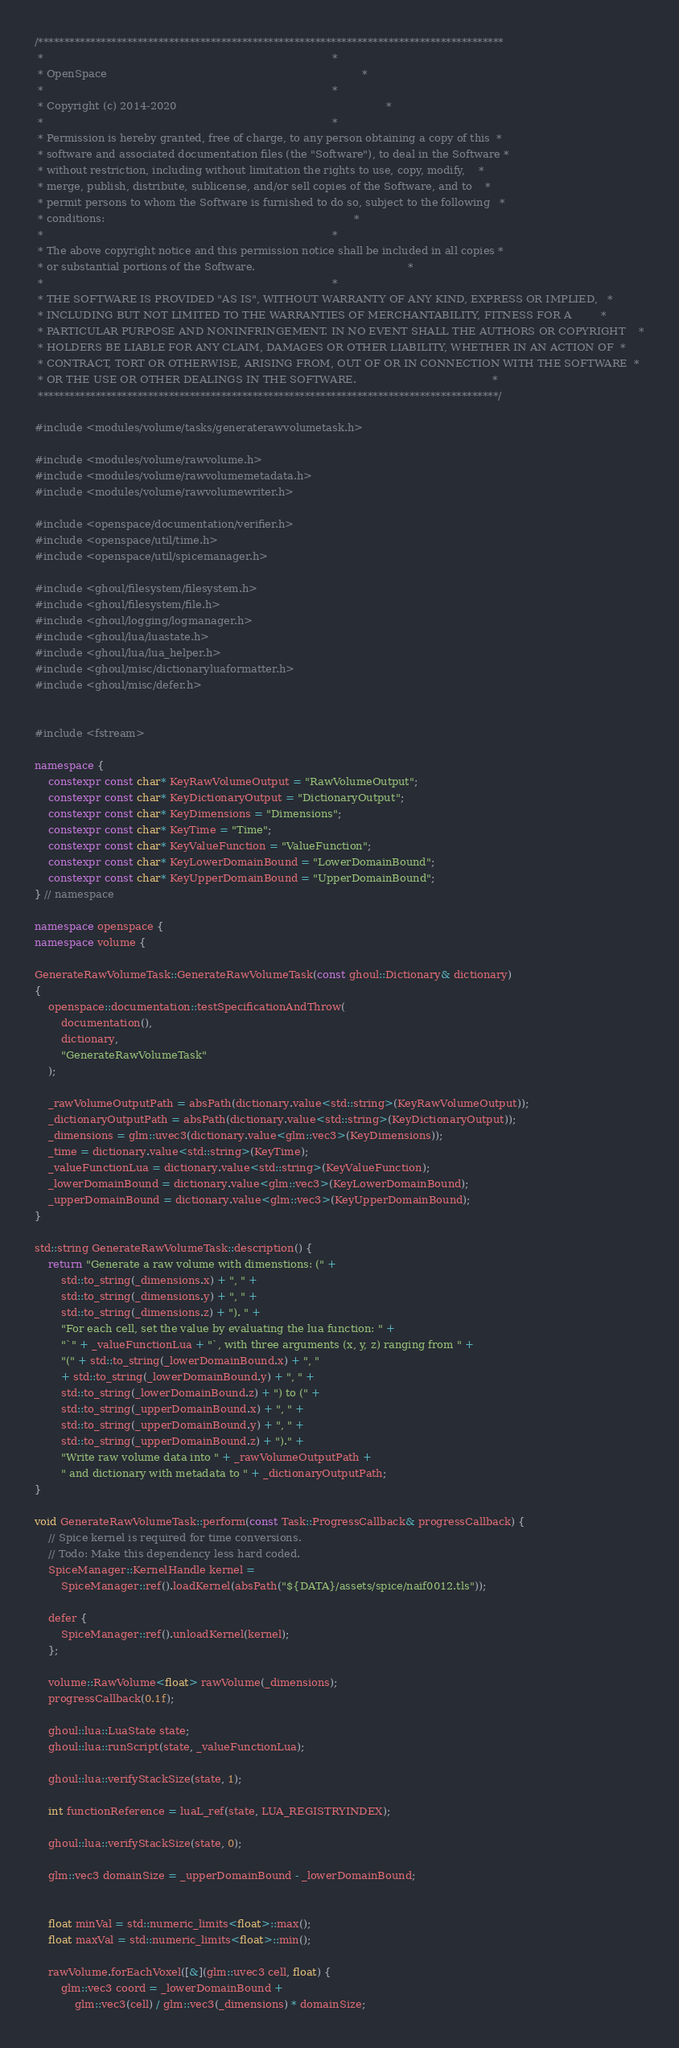<code> <loc_0><loc_0><loc_500><loc_500><_C++_>/*****************************************************************************************
 *                                                                                       *
 * OpenSpace                                                                             *
 *                                                                                       *
 * Copyright (c) 2014-2020                                                               *
 *                                                                                       *
 * Permission is hereby granted, free of charge, to any person obtaining a copy of this  *
 * software and associated documentation files (the "Software"), to deal in the Software *
 * without restriction, including without limitation the rights to use, copy, modify,    *
 * merge, publish, distribute, sublicense, and/or sell copies of the Software, and to    *
 * permit persons to whom the Software is furnished to do so, subject to the following   *
 * conditions:                                                                           *
 *                                                                                       *
 * The above copyright notice and this permission notice shall be included in all copies *
 * or substantial portions of the Software.                                              *
 *                                                                                       *
 * THE SOFTWARE IS PROVIDED "AS IS", WITHOUT WARRANTY OF ANY KIND, EXPRESS OR IMPLIED,   *
 * INCLUDING BUT NOT LIMITED TO THE WARRANTIES OF MERCHANTABILITY, FITNESS FOR A         *
 * PARTICULAR PURPOSE AND NONINFRINGEMENT. IN NO EVENT SHALL THE AUTHORS OR COPYRIGHT    *
 * HOLDERS BE LIABLE FOR ANY CLAIM, DAMAGES OR OTHER LIABILITY, WHETHER IN AN ACTION OF  *
 * CONTRACT, TORT OR OTHERWISE, ARISING FROM, OUT OF OR IN CONNECTION WITH THE SOFTWARE  *
 * OR THE USE OR OTHER DEALINGS IN THE SOFTWARE.                                         *
 ****************************************************************************************/

#include <modules/volume/tasks/generaterawvolumetask.h>

#include <modules/volume/rawvolume.h>
#include <modules/volume/rawvolumemetadata.h>
#include <modules/volume/rawvolumewriter.h>

#include <openspace/documentation/verifier.h>
#include <openspace/util/time.h>
#include <openspace/util/spicemanager.h>

#include <ghoul/filesystem/filesystem.h>
#include <ghoul/filesystem/file.h>
#include <ghoul/logging/logmanager.h>
#include <ghoul/lua/luastate.h>
#include <ghoul/lua/lua_helper.h>
#include <ghoul/misc/dictionaryluaformatter.h>
#include <ghoul/misc/defer.h>


#include <fstream>

namespace {
    constexpr const char* KeyRawVolumeOutput = "RawVolumeOutput";
    constexpr const char* KeyDictionaryOutput = "DictionaryOutput";
    constexpr const char* KeyDimensions = "Dimensions";
    constexpr const char* KeyTime = "Time";
    constexpr const char* KeyValueFunction = "ValueFunction";
    constexpr const char* KeyLowerDomainBound = "LowerDomainBound";
    constexpr const char* KeyUpperDomainBound = "UpperDomainBound";
} // namespace

namespace openspace {
namespace volume {

GenerateRawVolumeTask::GenerateRawVolumeTask(const ghoul::Dictionary& dictionary)
{
    openspace::documentation::testSpecificationAndThrow(
        documentation(),
        dictionary,
        "GenerateRawVolumeTask"
    );

    _rawVolumeOutputPath = absPath(dictionary.value<std::string>(KeyRawVolumeOutput));
    _dictionaryOutputPath = absPath(dictionary.value<std::string>(KeyDictionaryOutput));
    _dimensions = glm::uvec3(dictionary.value<glm::vec3>(KeyDimensions));
    _time = dictionary.value<std::string>(KeyTime);
    _valueFunctionLua = dictionary.value<std::string>(KeyValueFunction);
    _lowerDomainBound = dictionary.value<glm::vec3>(KeyLowerDomainBound);
    _upperDomainBound = dictionary.value<glm::vec3>(KeyUpperDomainBound);
}

std::string GenerateRawVolumeTask::description() {
    return "Generate a raw volume with dimenstions: (" +
        std::to_string(_dimensions.x) + ", " +
        std::to_string(_dimensions.y) + ", " +
        std::to_string(_dimensions.z) + "). " +
        "For each cell, set the value by evaluating the lua function: " +
        "`" + _valueFunctionLua + "`, with three arguments (x, y, z) ranging from " +
        "(" + std::to_string(_lowerDomainBound.x) + ", "
        + std::to_string(_lowerDomainBound.y) + ", " +
        std::to_string(_lowerDomainBound.z) + ") to (" +
        std::to_string(_upperDomainBound.x) + ", " +
        std::to_string(_upperDomainBound.y) + ", " +
        std::to_string(_upperDomainBound.z) + ")." +
        "Write raw volume data into " + _rawVolumeOutputPath +
        " and dictionary with metadata to " + _dictionaryOutputPath;
}

void GenerateRawVolumeTask::perform(const Task::ProgressCallback& progressCallback) {
    // Spice kernel is required for time conversions.
    // Todo: Make this dependency less hard coded.
    SpiceManager::KernelHandle kernel =
        SpiceManager::ref().loadKernel(absPath("${DATA}/assets/spice/naif0012.tls"));

    defer {
        SpiceManager::ref().unloadKernel(kernel);
    };

    volume::RawVolume<float> rawVolume(_dimensions);
    progressCallback(0.1f);

    ghoul::lua::LuaState state;
    ghoul::lua::runScript(state, _valueFunctionLua);

    ghoul::lua::verifyStackSize(state, 1);

    int functionReference = luaL_ref(state, LUA_REGISTRYINDEX);

    ghoul::lua::verifyStackSize(state, 0);

    glm::vec3 domainSize = _upperDomainBound - _lowerDomainBound;


    float minVal = std::numeric_limits<float>::max();
    float maxVal = std::numeric_limits<float>::min();

    rawVolume.forEachVoxel([&](glm::uvec3 cell, float) {
        glm::vec3 coord = _lowerDomainBound +
            glm::vec3(cell) / glm::vec3(_dimensions) * domainSize;
</code> 